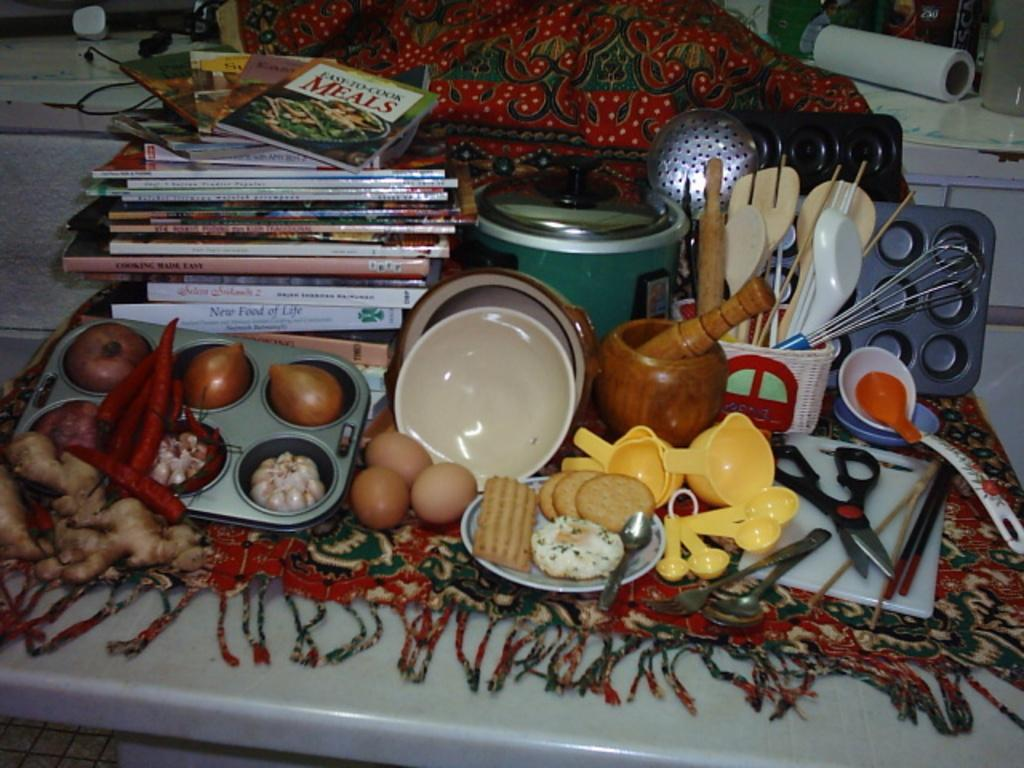<image>
Summarize the visual content of the image. Esy-To-Cook Meal is the top book on a stack of many cookbooks which are surrounded by kitchen supplies. 